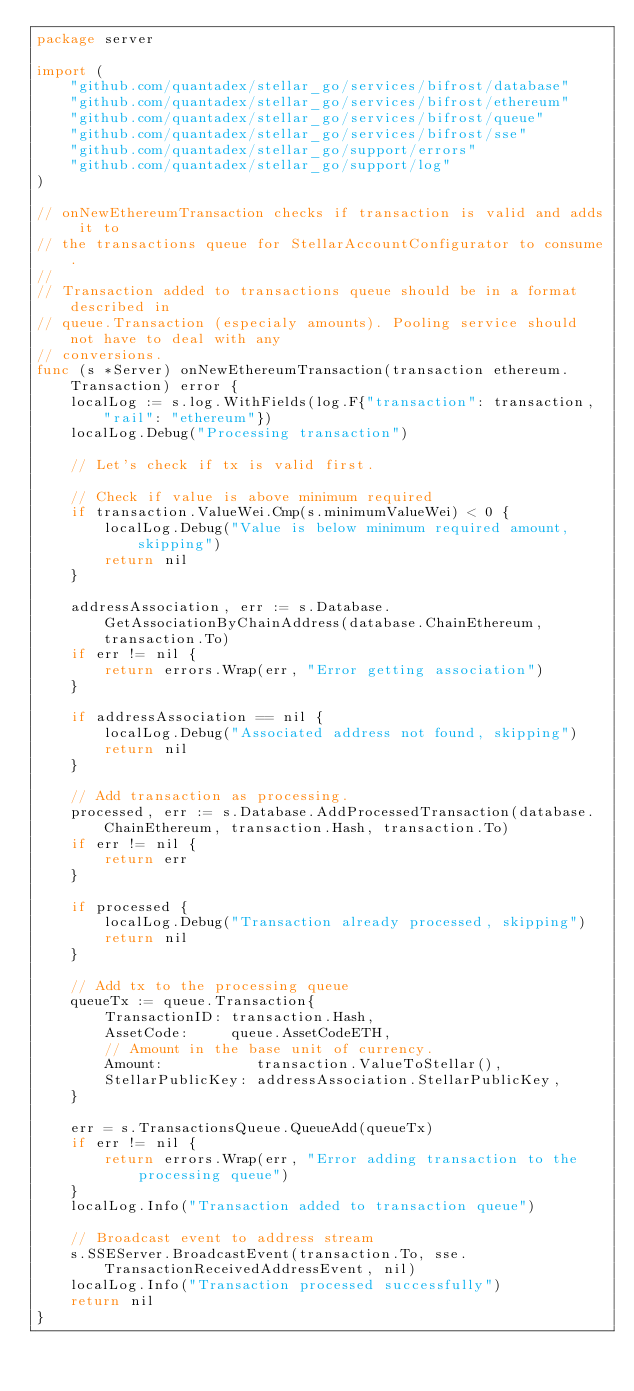Convert code to text. <code><loc_0><loc_0><loc_500><loc_500><_Go_>package server

import (
	"github.com/quantadex/stellar_go/services/bifrost/database"
	"github.com/quantadex/stellar_go/services/bifrost/ethereum"
	"github.com/quantadex/stellar_go/services/bifrost/queue"
	"github.com/quantadex/stellar_go/services/bifrost/sse"
	"github.com/quantadex/stellar_go/support/errors"
	"github.com/quantadex/stellar_go/support/log"
)

// onNewEthereumTransaction checks if transaction is valid and adds it to
// the transactions queue for StellarAccountConfigurator to consume.
//
// Transaction added to transactions queue should be in a format described in
// queue.Transaction (especialy amounts). Pooling service should not have to deal with any
// conversions.
func (s *Server) onNewEthereumTransaction(transaction ethereum.Transaction) error {
	localLog := s.log.WithFields(log.F{"transaction": transaction, "rail": "ethereum"})
	localLog.Debug("Processing transaction")

	// Let's check if tx is valid first.

	// Check if value is above minimum required
	if transaction.ValueWei.Cmp(s.minimumValueWei) < 0 {
		localLog.Debug("Value is below minimum required amount, skipping")
		return nil
	}

	addressAssociation, err := s.Database.GetAssociationByChainAddress(database.ChainEthereum, transaction.To)
	if err != nil {
		return errors.Wrap(err, "Error getting association")
	}

	if addressAssociation == nil {
		localLog.Debug("Associated address not found, skipping")
		return nil
	}

	// Add transaction as processing.
	processed, err := s.Database.AddProcessedTransaction(database.ChainEthereum, transaction.Hash, transaction.To)
	if err != nil {
		return err
	}

	if processed {
		localLog.Debug("Transaction already processed, skipping")
		return nil
	}

	// Add tx to the processing queue
	queueTx := queue.Transaction{
		TransactionID: transaction.Hash,
		AssetCode:     queue.AssetCodeETH,
		// Amount in the base unit of currency.
		Amount:           transaction.ValueToStellar(),
		StellarPublicKey: addressAssociation.StellarPublicKey,
	}

	err = s.TransactionsQueue.QueueAdd(queueTx)
	if err != nil {
		return errors.Wrap(err, "Error adding transaction to the processing queue")
	}
	localLog.Info("Transaction added to transaction queue")

	// Broadcast event to address stream
	s.SSEServer.BroadcastEvent(transaction.To, sse.TransactionReceivedAddressEvent, nil)
	localLog.Info("Transaction processed successfully")
	return nil
}
</code> 